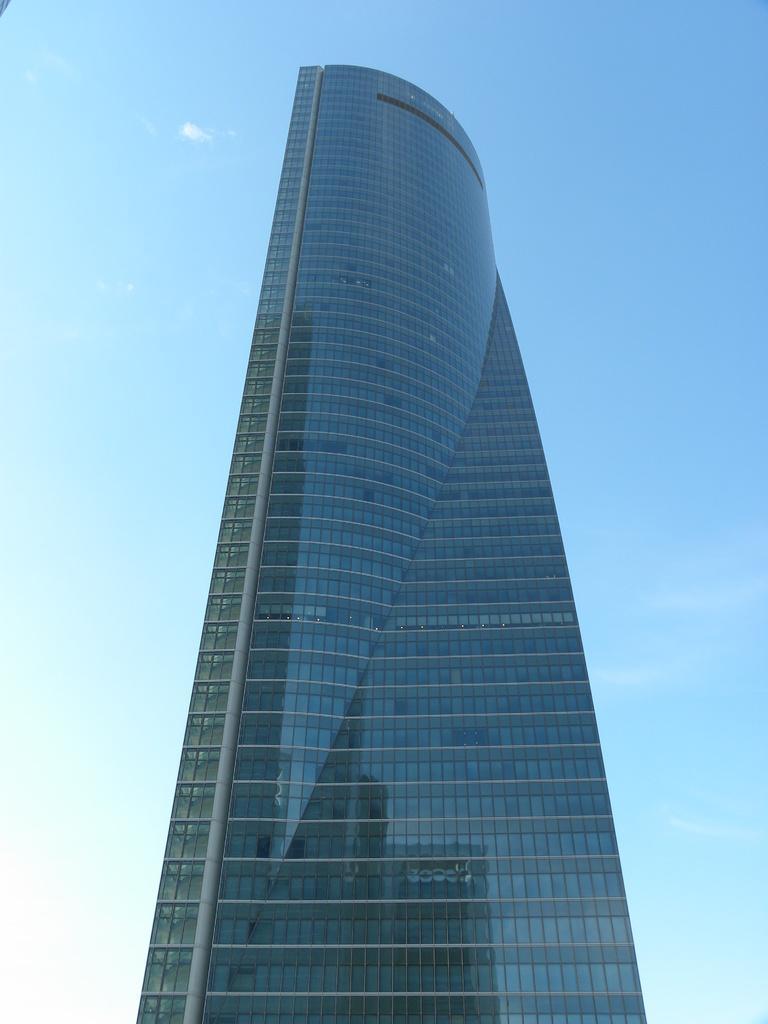Describe this image in one or two sentences. In the center of the image there is a building. In the background there is sky and clouds. 